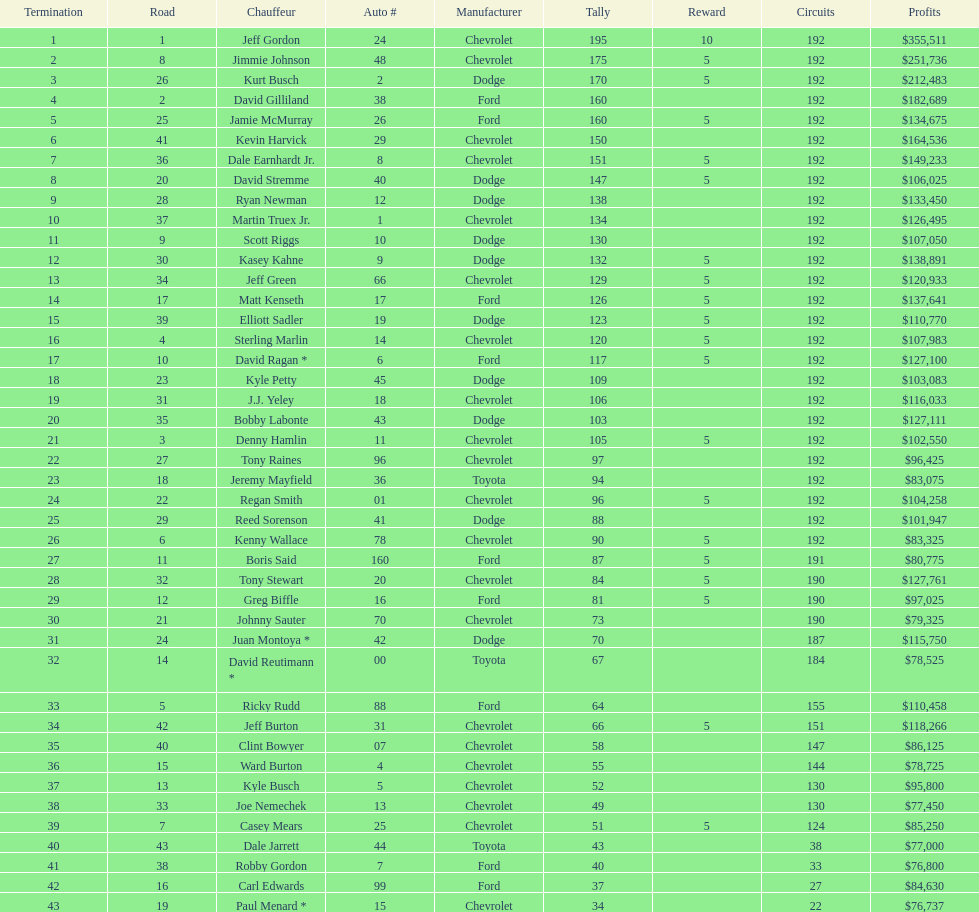How many race car drivers out of the 43 listed drove toyotas? 3. 